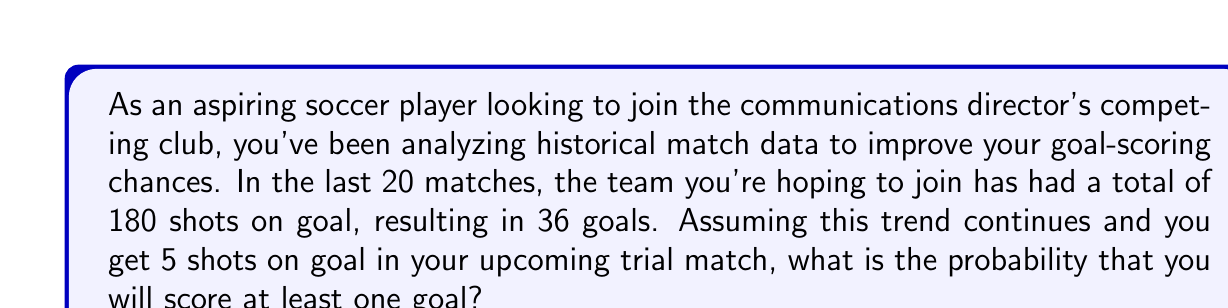Can you solve this math problem? Let's approach this step-by-step:

1) First, we need to calculate the probability of scoring a goal on a single shot. 
   From the given data:
   $$ P(\text{goal | shot}) = \frac{\text{Number of goals}}{\text{Number of shots}} = \frac{36}{180} = 0.2 $$

2) This means the probability of not scoring on a single shot is:
   $$ P(\text{no goal | shot}) = 1 - P(\text{goal | shot}) = 1 - 0.2 = 0.8 $$

3) Now, we want to find the probability of scoring at least one goal in 5 shots. This is equivalent to 1 minus the probability of not scoring on any of the 5 shots.

4) The probability of not scoring on any of the 5 shots is:
   $$ P(\text{no goals in 5 shots}) = (0.8)^5 = 0.32768 $$

5) Therefore, the probability of scoring at least one goal in 5 shots is:
   $$ P(\text{at least one goal in 5 shots}) = 1 - P(\text{no goals in 5 shots}) $$
   $$ = 1 - 0.32768 = 0.67232 $$

6) Converting to a percentage:
   $$ 0.67232 \times 100\% = 67.232\% $$
Answer: The probability of scoring at least one goal in your upcoming trial match, given 5 shots on goal, is approximately 67.23%. 